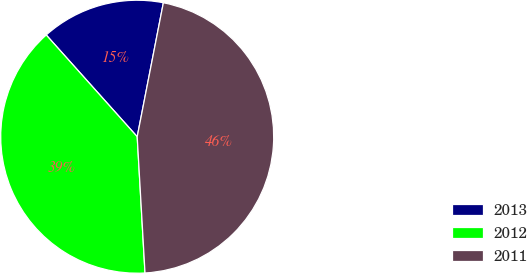Convert chart to OTSL. <chart><loc_0><loc_0><loc_500><loc_500><pie_chart><fcel>2013<fcel>2012<fcel>2011<nl><fcel>14.68%<fcel>39.3%<fcel>46.02%<nl></chart> 